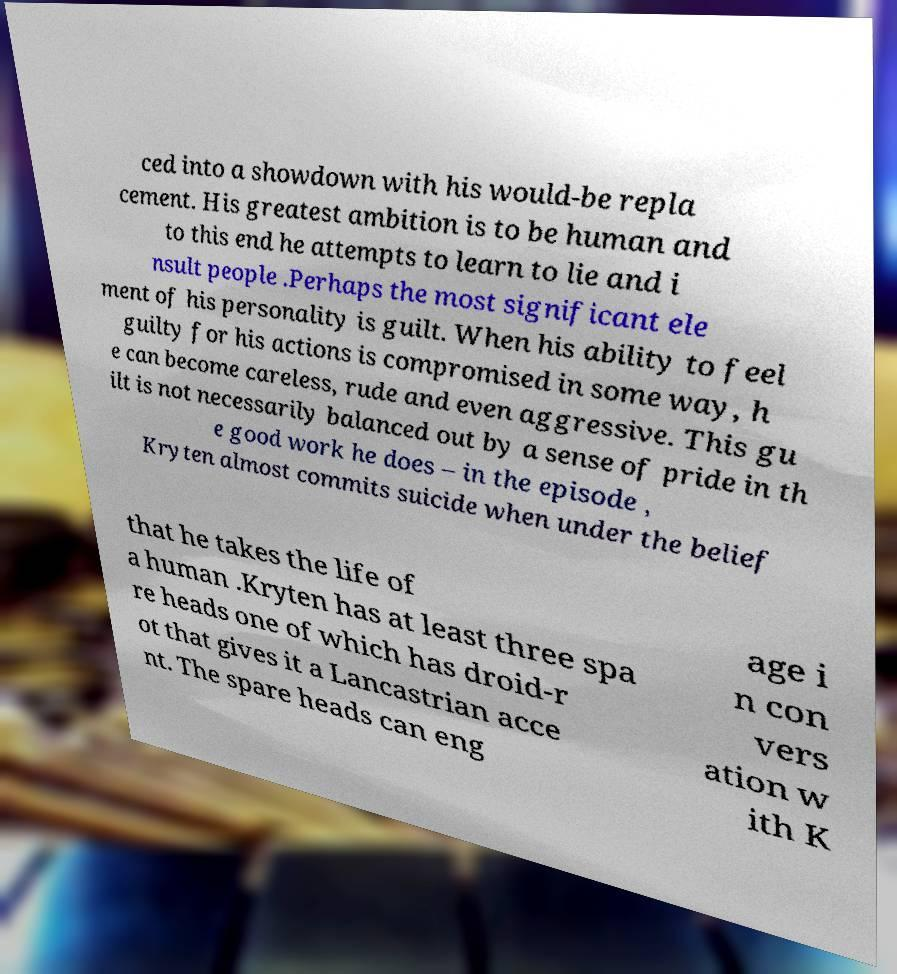For documentation purposes, I need the text within this image transcribed. Could you provide that? ced into a showdown with his would-be repla cement. His greatest ambition is to be human and to this end he attempts to learn to lie and i nsult people .Perhaps the most significant ele ment of his personality is guilt. When his ability to feel guilty for his actions is compromised in some way, h e can become careless, rude and even aggressive. This gu ilt is not necessarily balanced out by a sense of pride in th e good work he does – in the episode , Kryten almost commits suicide when under the belief that he takes the life of a human .Kryten has at least three spa re heads one of which has droid-r ot that gives it a Lancastrian acce nt. The spare heads can eng age i n con vers ation w ith K 